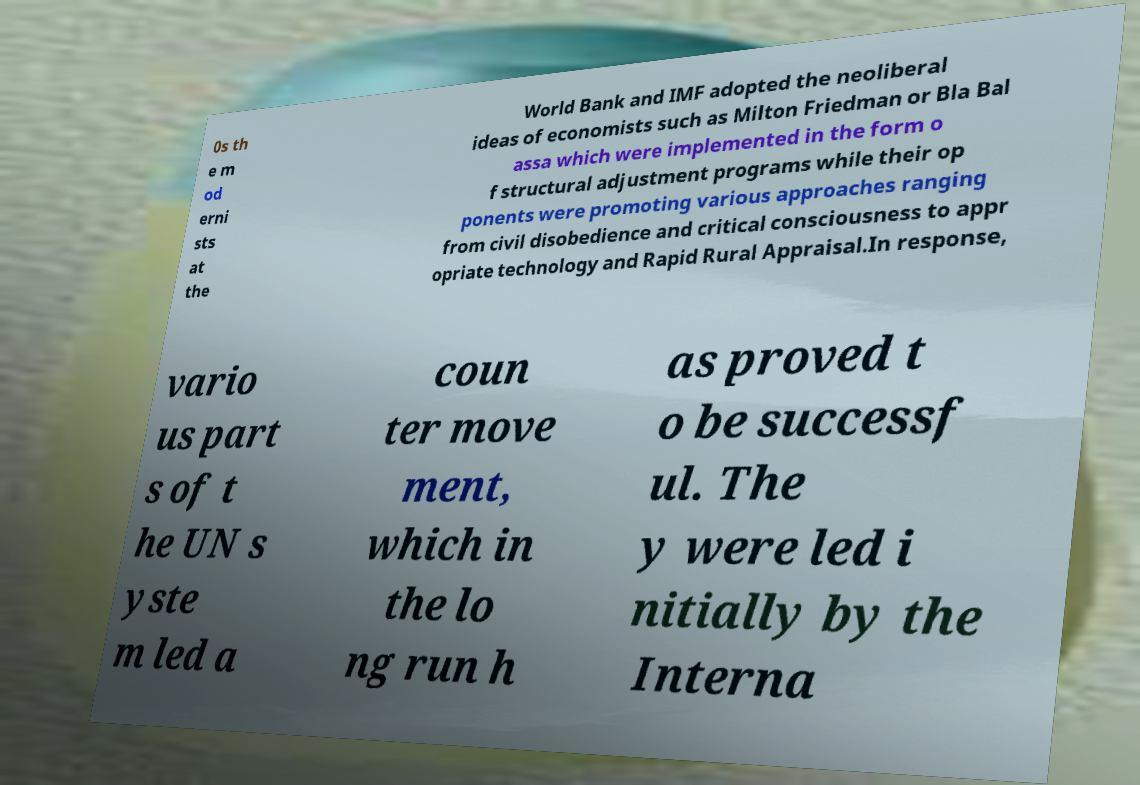There's text embedded in this image that I need extracted. Can you transcribe it verbatim? 0s th e m od erni sts at the World Bank and IMF adopted the neoliberal ideas of economists such as Milton Friedman or Bla Bal assa which were implemented in the form o f structural adjustment programs while their op ponents were promoting various approaches ranging from civil disobedience and critical consciousness to appr opriate technology and Rapid Rural Appraisal.In response, vario us part s of t he UN s yste m led a coun ter move ment, which in the lo ng run h as proved t o be successf ul. The y were led i nitially by the Interna 